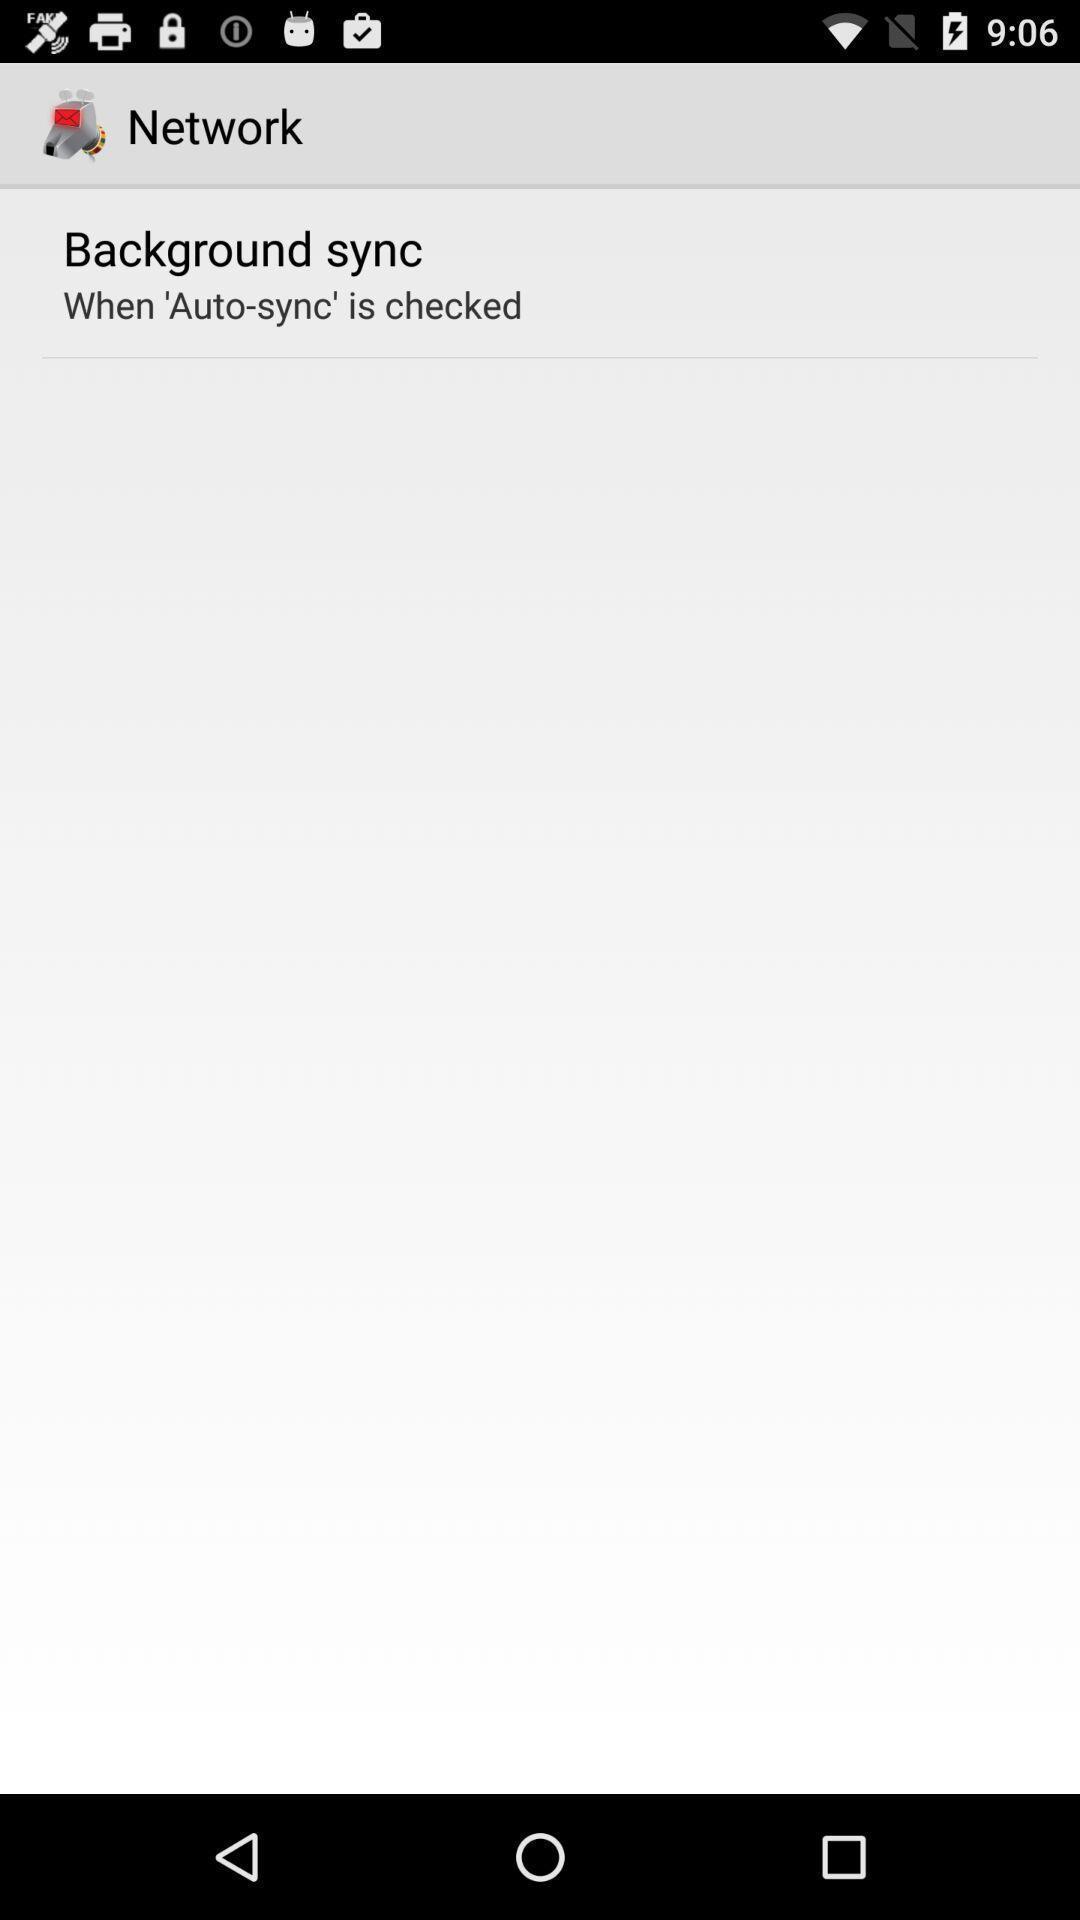Describe the content in this image. Page showing background sync option. 